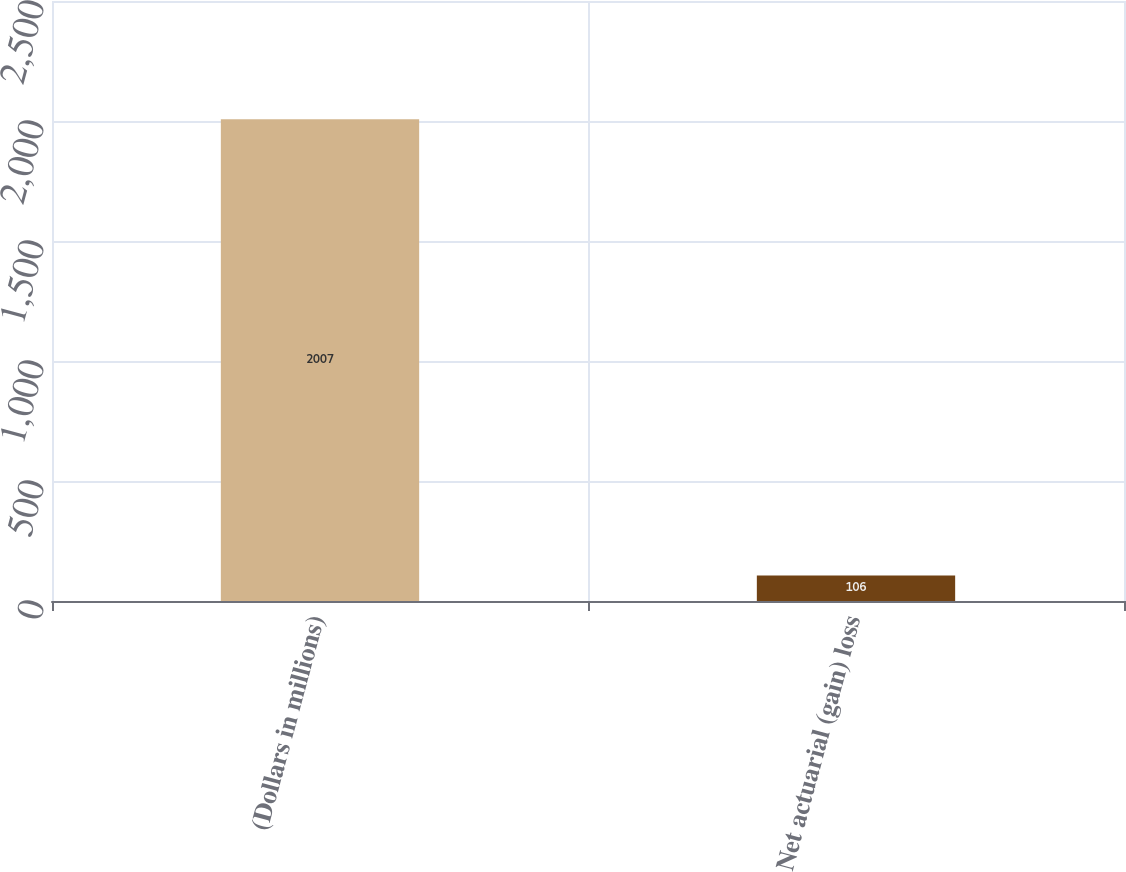Convert chart. <chart><loc_0><loc_0><loc_500><loc_500><bar_chart><fcel>(Dollars in millions)<fcel>Net actuarial (gain) loss<nl><fcel>2007<fcel>106<nl></chart> 